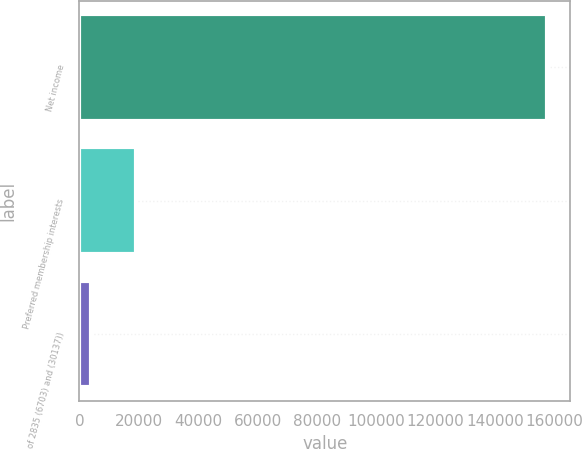Convert chart to OTSL. <chart><loc_0><loc_0><loc_500><loc_500><bar_chart><fcel>Net income<fcel>Preferred membership interests<fcel>of 2835 (6703) and (30137))<nl><fcel>157543<fcel>19132<fcel>3753<nl></chart> 